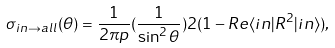Convert formula to latex. <formula><loc_0><loc_0><loc_500><loc_500>\sigma _ { i n \to a l l } ( \theta ) = \frac { 1 } { 2 \pi p } ( \frac { 1 } { \sin ^ { 2 } \theta } ) 2 ( 1 - R e \langle i n | R ^ { 2 } | i n \rangle ) ,</formula> 